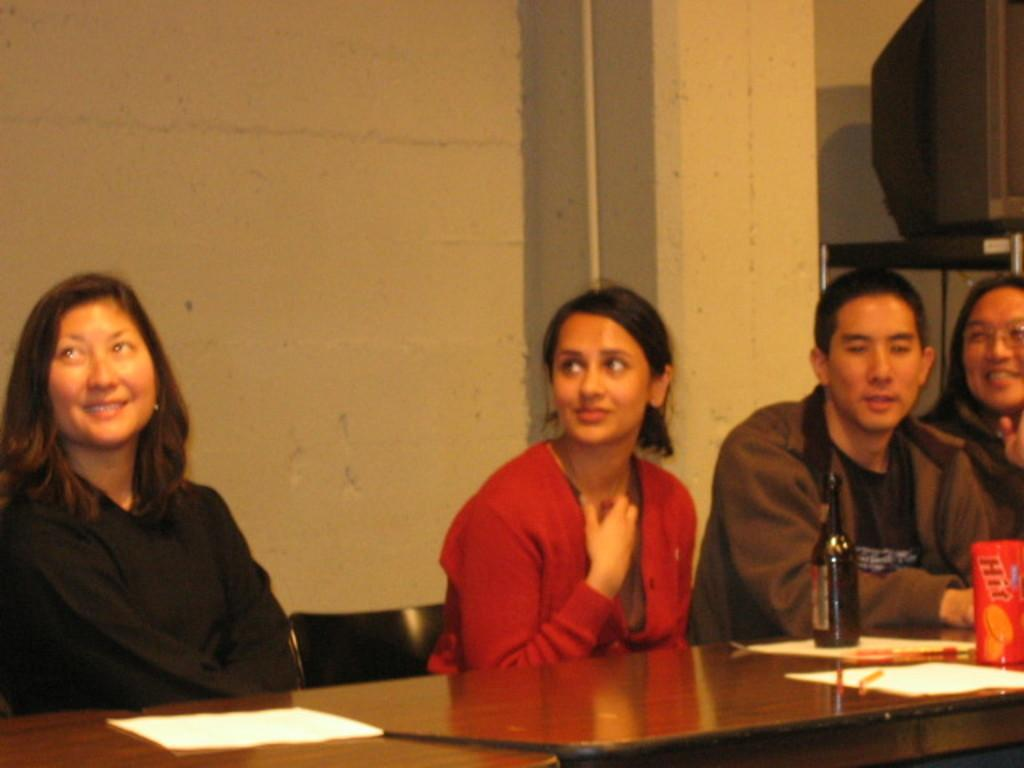What are the people in the image doing? The people in the image are sitting in front of a table. What can be seen on the table? There is a bottle on the table, along with other objects. What is visible in the background of the image? There is a wall in the background, and other objects are visible as well. How many apples are being copied by the people in the image? There are no apples present in the image, nor is there any indication of copying. 